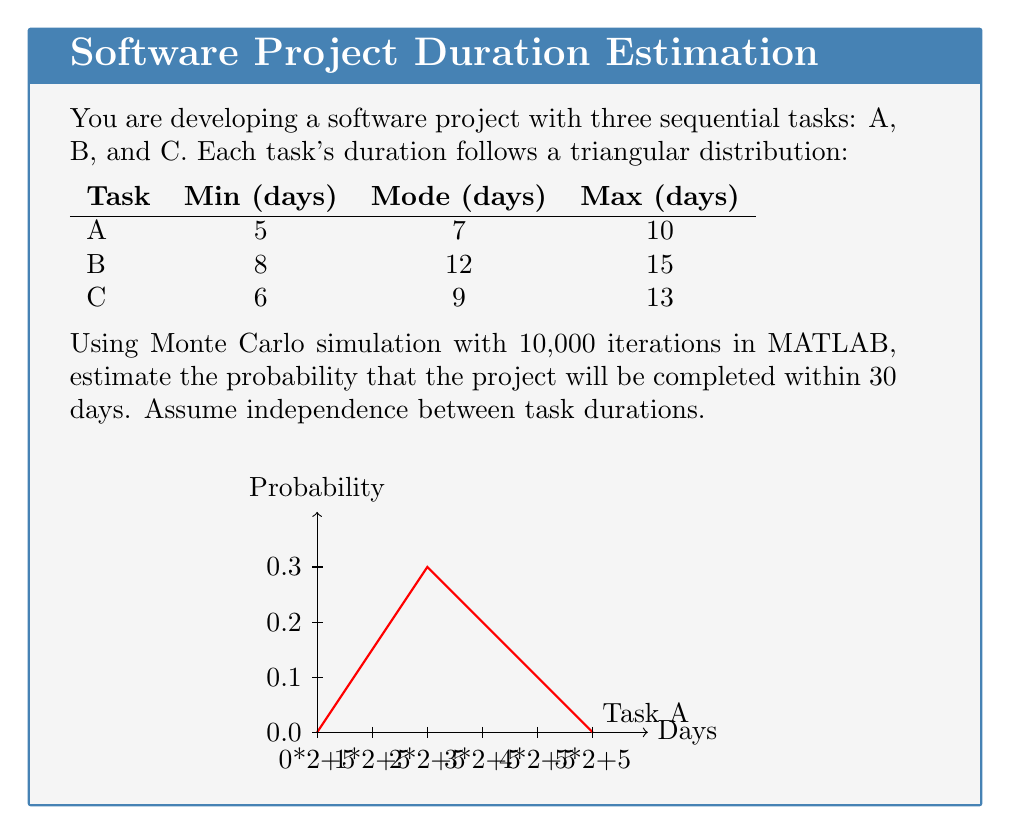Teach me how to tackle this problem. To solve this problem using Monte Carlo simulation in MATLAB, we'll follow these steps:

1) Set up the triangular distributions for each task:
   For a triangular distribution with parameters (a, b, c), we can generate random numbers using:
   $$r = a + (b-a)\sqrt{u} \text{ if } u < \frac{b-a}{c-a}, \text{ else } c - (c-b)\sqrt{1-u}$$
   where $u$ is a uniform random number between 0 and 1.

2) Create a MATLAB function to generate random numbers from a triangular distribution:

```matlab
function x = trirand(a, b, c, n)
    u = rand(n,1);
    k = (b-a)/(c-a);
    x = zeros(n,1);
    x(u<k) = a + sqrt(u(u<k).*k*(c-a)*(b-a));
    x(u>=k) = c - sqrt((1-u(u>=k)).*(1-k)*(c-a)*(c-b));
end
```

3) Run the Monte Carlo simulation:

```matlab
n = 10000;
A = trirand(5, 7, 10, n);
B = trirand(8, 12, 15, n);
C = trirand(6, 9, 13, n);

total_duration = A + B + C;
probability = sum(total_duration <= 30) / n;
```

4) Interpret the results:
   The variable `probability` will contain the estimated probability of completing the project within 30 days.

5) For a more accurate result, we could increase the number of iterations (n) or run the simulation multiple times and take the average.

The exact probability will vary slightly each time due to the random nature of Monte Carlo simulation, but it should converge to a stable value as the number of iterations increases.
Answer: Approximately $0.48$ (or $48\%$), with slight variations due to randomness. 